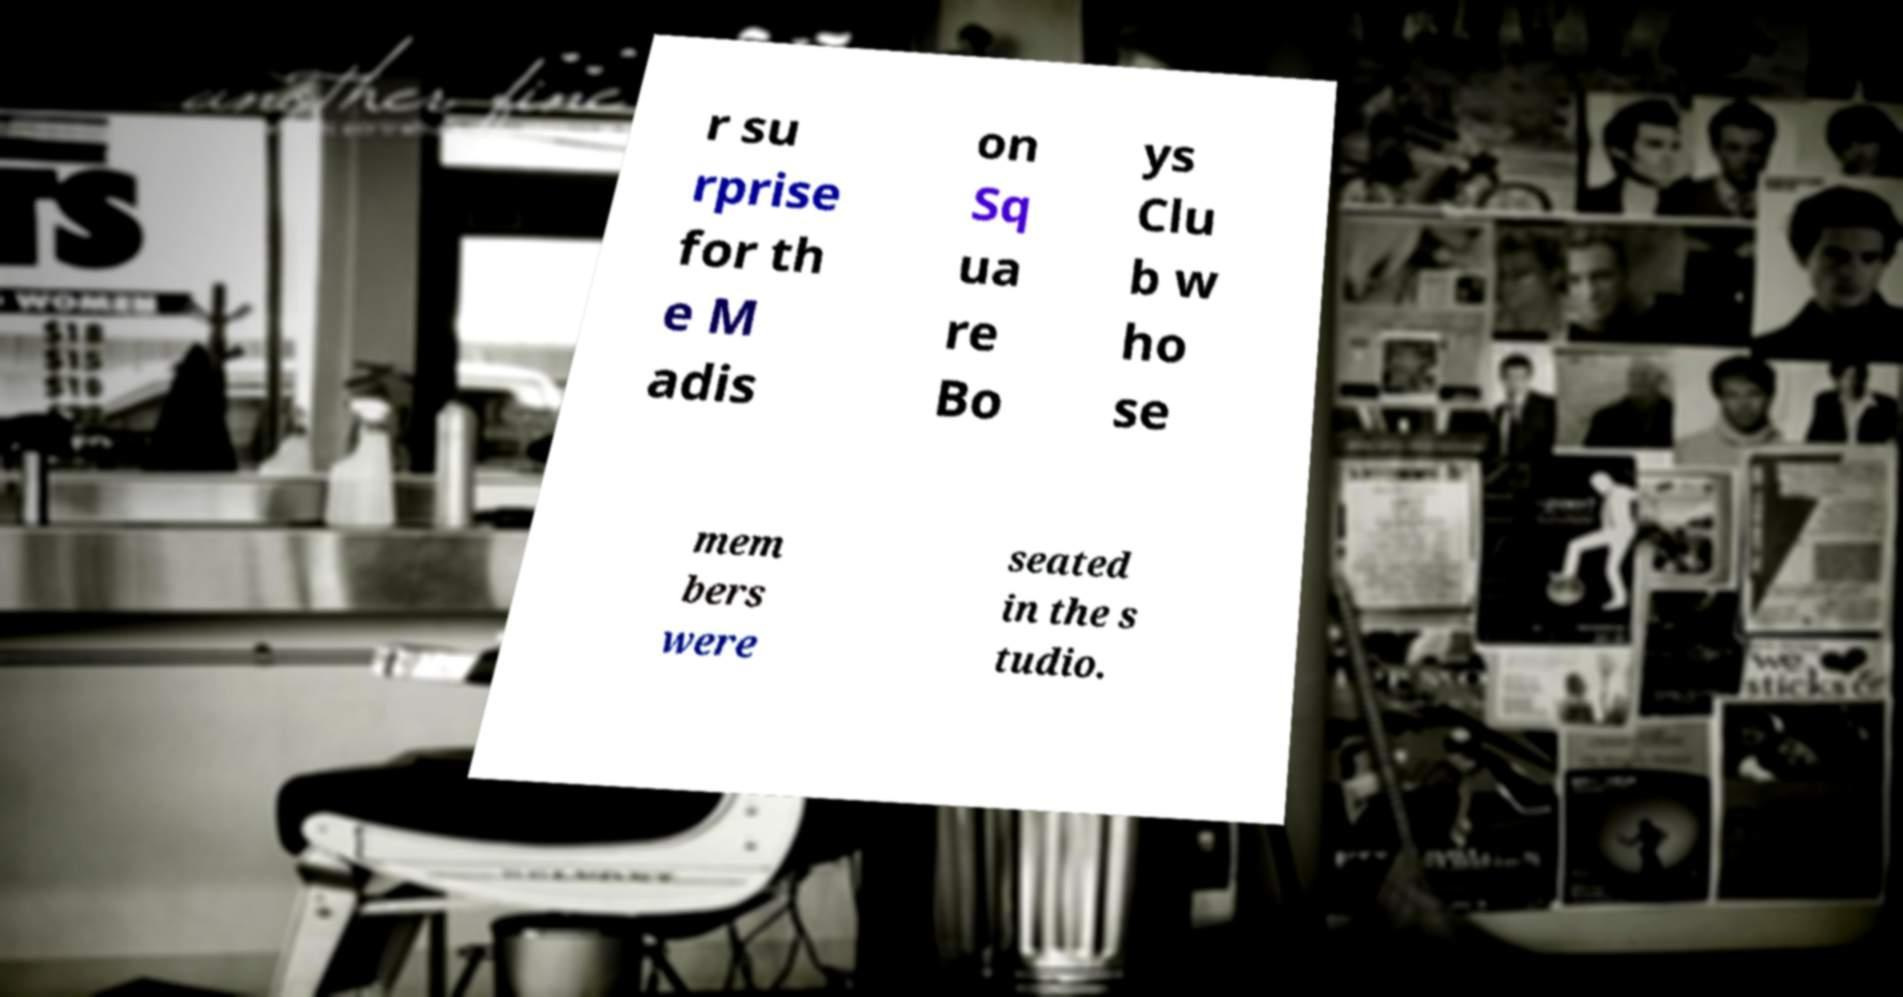Can you accurately transcribe the text from the provided image for me? r su rprise for th e M adis on Sq ua re Bo ys Clu b w ho se mem bers were seated in the s tudio. 